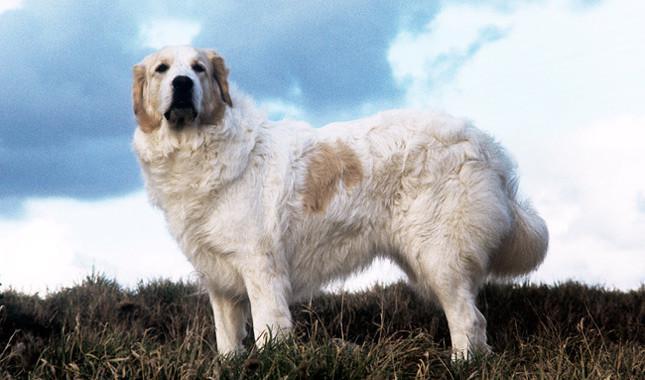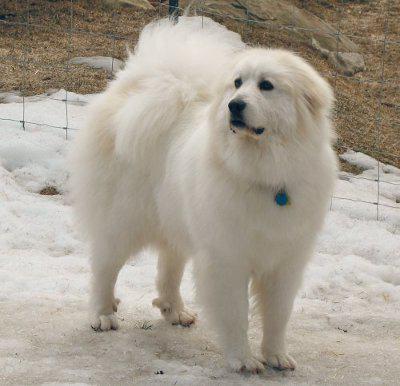The first image is the image on the left, the second image is the image on the right. Considering the images on both sides, is "There is a dog standing in snow in the images." valid? Answer yes or no. Yes. 